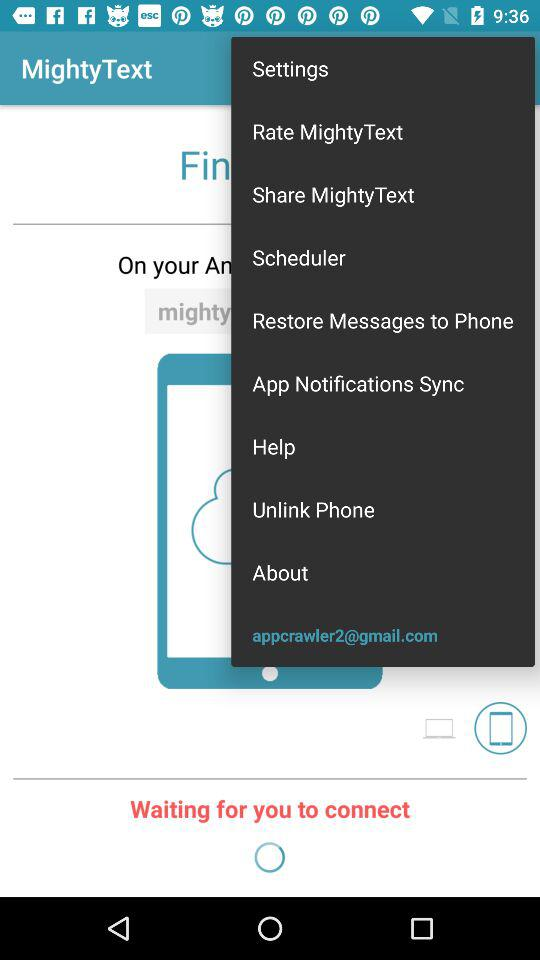What is the email address? The email address is appcrawler2@gmail.com. 